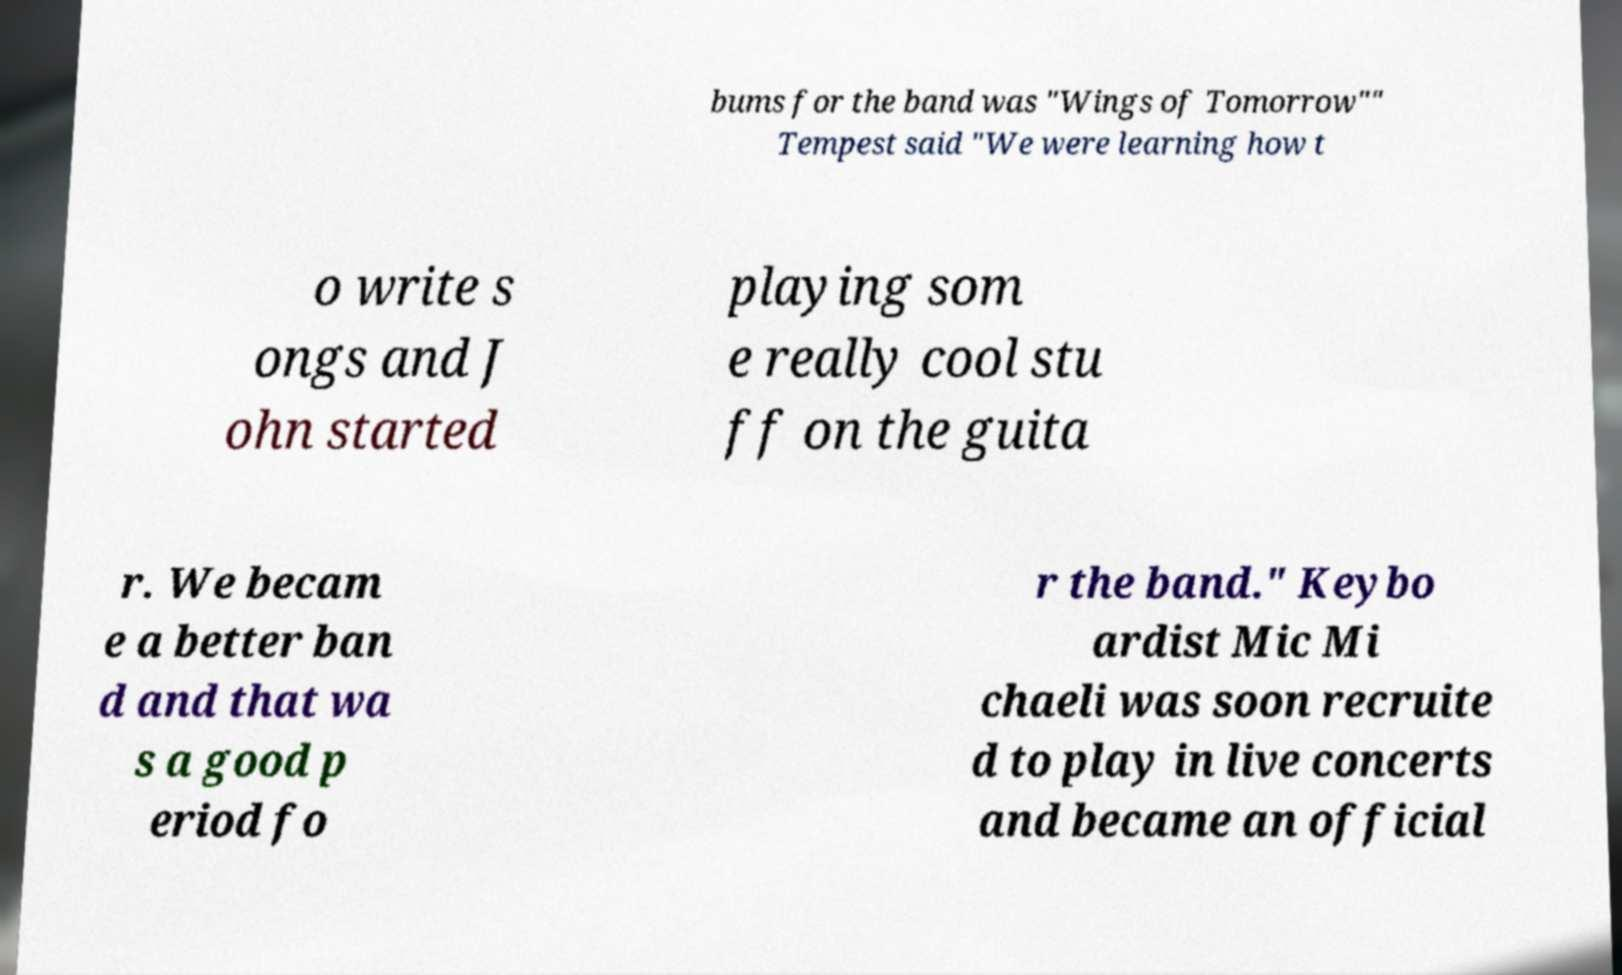Please identify and transcribe the text found in this image. bums for the band was "Wings of Tomorrow"" Tempest said "We were learning how t o write s ongs and J ohn started playing som e really cool stu ff on the guita r. We becam e a better ban d and that wa s a good p eriod fo r the band." Keybo ardist Mic Mi chaeli was soon recruite d to play in live concerts and became an official 